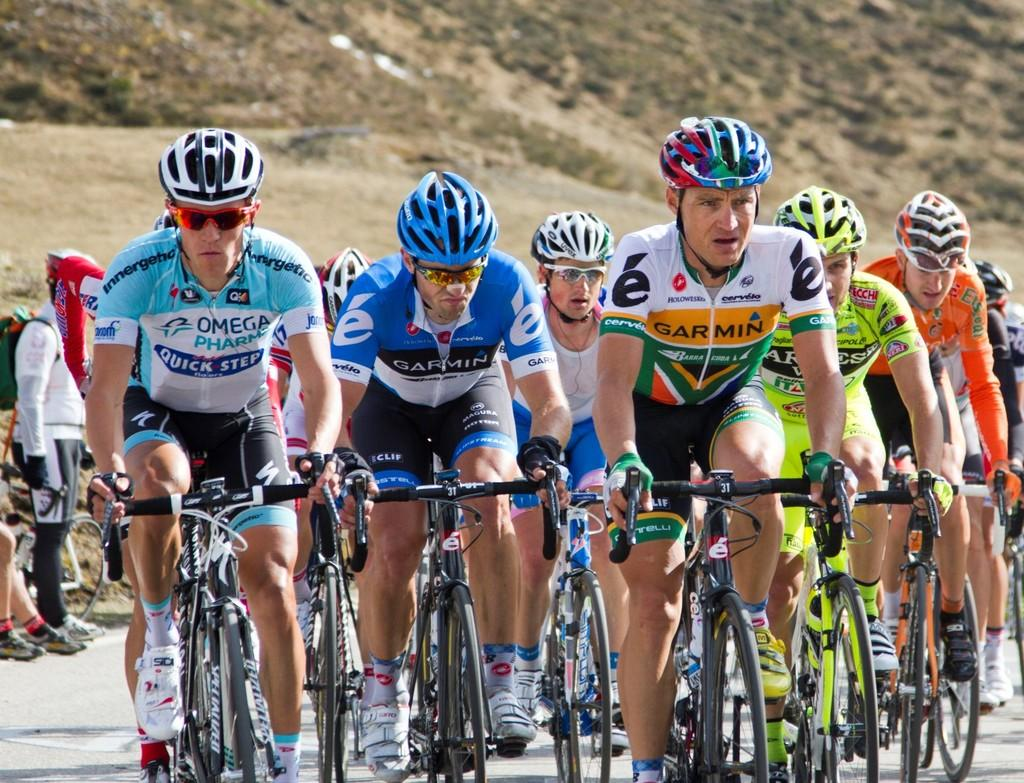What is the main activity being performed by the group of men in the image? The men are cycling in the image. What type of clothing are the men wearing? The men are wearing t-shirts and helmets. Where is the cycling taking place? The cycling is taking place on a street. What can be seen in the background of the image? There is a mountain visible in the background of the image. Can you see a rabbit holding a yoke while playing basketball in the image? No, there is no rabbit, yoke, or basketball present in the image. 